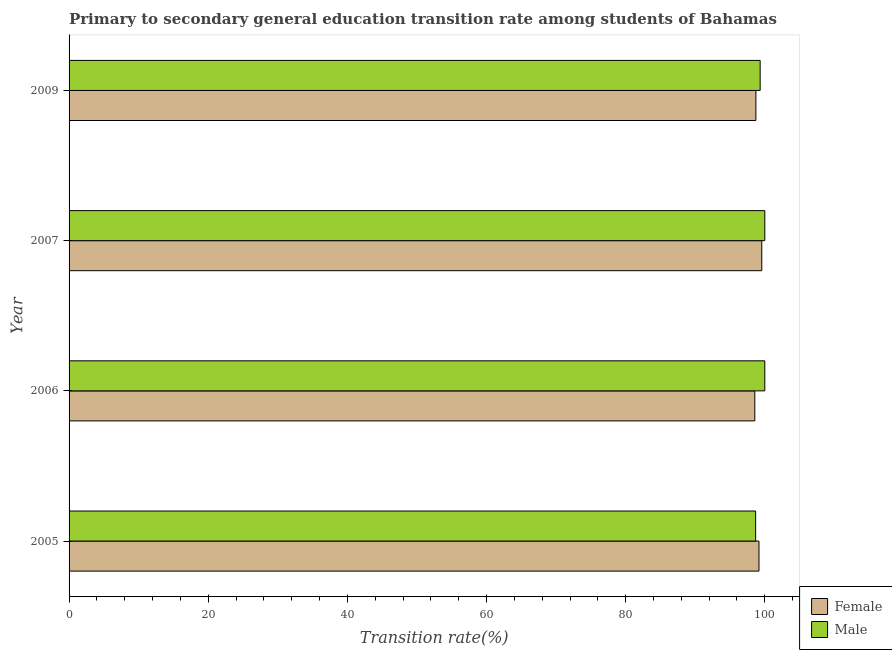How many different coloured bars are there?
Offer a very short reply. 2. How many groups of bars are there?
Your answer should be very brief. 4. Are the number of bars per tick equal to the number of legend labels?
Your response must be concise. Yes. How many bars are there on the 2nd tick from the top?
Make the answer very short. 2. How many bars are there on the 2nd tick from the bottom?
Make the answer very short. 2. What is the transition rate among female students in 2009?
Your answer should be very brief. 98.72. Across all years, what is the maximum transition rate among male students?
Offer a terse response. 100. Across all years, what is the minimum transition rate among male students?
Ensure brevity in your answer.  98.68. In which year was the transition rate among female students minimum?
Make the answer very short. 2006. What is the total transition rate among female students in the graph?
Provide a short and direct response. 396.01. What is the difference between the transition rate among female students in 2007 and that in 2009?
Your answer should be very brief. 0.85. What is the difference between the transition rate among male students in 2005 and the transition rate among female students in 2007?
Your answer should be compact. -0.88. What is the average transition rate among female students per year?
Give a very brief answer. 99. In the year 2009, what is the difference between the transition rate among male students and transition rate among female students?
Make the answer very short. 0.61. In how many years, is the transition rate among male students greater than the average transition rate among male students taken over all years?
Your answer should be very brief. 2. What does the 1st bar from the top in 2006 represents?
Provide a succinct answer. Male. What does the 1st bar from the bottom in 2007 represents?
Your answer should be very brief. Female. Are all the bars in the graph horizontal?
Provide a short and direct response. Yes. What is the difference between two consecutive major ticks on the X-axis?
Make the answer very short. 20. Does the graph contain any zero values?
Offer a terse response. No. Does the graph contain grids?
Offer a terse response. No. How are the legend labels stacked?
Your answer should be compact. Vertical. What is the title of the graph?
Make the answer very short. Primary to secondary general education transition rate among students of Bahamas. Does "Goods and services" appear as one of the legend labels in the graph?
Ensure brevity in your answer.  No. What is the label or title of the X-axis?
Offer a terse response. Transition rate(%). What is the Transition rate(%) in Female in 2005?
Provide a succinct answer. 99.17. What is the Transition rate(%) of Male in 2005?
Your answer should be compact. 98.68. What is the Transition rate(%) in Female in 2006?
Provide a succinct answer. 98.57. What is the Transition rate(%) of Male in 2006?
Make the answer very short. 100. What is the Transition rate(%) of Female in 2007?
Your answer should be very brief. 99.56. What is the Transition rate(%) of Male in 2007?
Offer a terse response. 100. What is the Transition rate(%) in Female in 2009?
Your response must be concise. 98.72. What is the Transition rate(%) in Male in 2009?
Keep it short and to the point. 99.33. Across all years, what is the maximum Transition rate(%) in Female?
Your response must be concise. 99.56. Across all years, what is the maximum Transition rate(%) in Male?
Ensure brevity in your answer.  100. Across all years, what is the minimum Transition rate(%) of Female?
Make the answer very short. 98.57. Across all years, what is the minimum Transition rate(%) in Male?
Offer a very short reply. 98.68. What is the total Transition rate(%) of Female in the graph?
Provide a succinct answer. 396.01. What is the total Transition rate(%) in Male in the graph?
Make the answer very short. 398.01. What is the difference between the Transition rate(%) of Female in 2005 and that in 2006?
Your answer should be compact. 0.6. What is the difference between the Transition rate(%) in Male in 2005 and that in 2006?
Provide a short and direct response. -1.32. What is the difference between the Transition rate(%) in Female in 2005 and that in 2007?
Make the answer very short. -0.4. What is the difference between the Transition rate(%) in Male in 2005 and that in 2007?
Your answer should be compact. -1.32. What is the difference between the Transition rate(%) in Female in 2005 and that in 2009?
Give a very brief answer. 0.45. What is the difference between the Transition rate(%) in Male in 2005 and that in 2009?
Your answer should be very brief. -0.65. What is the difference between the Transition rate(%) in Female in 2006 and that in 2007?
Provide a succinct answer. -1. What is the difference between the Transition rate(%) in Female in 2006 and that in 2009?
Your response must be concise. -0.15. What is the difference between the Transition rate(%) in Male in 2006 and that in 2009?
Make the answer very short. 0.67. What is the difference between the Transition rate(%) in Female in 2007 and that in 2009?
Provide a succinct answer. 0.85. What is the difference between the Transition rate(%) of Male in 2007 and that in 2009?
Provide a short and direct response. 0.67. What is the difference between the Transition rate(%) of Female in 2005 and the Transition rate(%) of Male in 2006?
Offer a terse response. -0.83. What is the difference between the Transition rate(%) of Female in 2005 and the Transition rate(%) of Male in 2007?
Your answer should be very brief. -0.83. What is the difference between the Transition rate(%) of Female in 2005 and the Transition rate(%) of Male in 2009?
Provide a succinct answer. -0.17. What is the difference between the Transition rate(%) in Female in 2006 and the Transition rate(%) in Male in 2007?
Ensure brevity in your answer.  -1.43. What is the difference between the Transition rate(%) in Female in 2006 and the Transition rate(%) in Male in 2009?
Make the answer very short. -0.77. What is the difference between the Transition rate(%) in Female in 2007 and the Transition rate(%) in Male in 2009?
Make the answer very short. 0.23. What is the average Transition rate(%) of Female per year?
Give a very brief answer. 99. What is the average Transition rate(%) of Male per year?
Your response must be concise. 99.5. In the year 2005, what is the difference between the Transition rate(%) of Female and Transition rate(%) of Male?
Your answer should be compact. 0.48. In the year 2006, what is the difference between the Transition rate(%) of Female and Transition rate(%) of Male?
Offer a very short reply. -1.43. In the year 2007, what is the difference between the Transition rate(%) of Female and Transition rate(%) of Male?
Your answer should be very brief. -0.44. In the year 2009, what is the difference between the Transition rate(%) of Female and Transition rate(%) of Male?
Give a very brief answer. -0.61. What is the ratio of the Transition rate(%) of Female in 2005 to that in 2006?
Offer a terse response. 1.01. What is the ratio of the Transition rate(%) of Male in 2005 to that in 2006?
Give a very brief answer. 0.99. What is the ratio of the Transition rate(%) of Female in 2005 to that in 2007?
Provide a succinct answer. 1. What is the ratio of the Transition rate(%) in Male in 2005 to that in 2007?
Provide a succinct answer. 0.99. What is the ratio of the Transition rate(%) of Female in 2006 to that in 2007?
Your answer should be very brief. 0.99. What is the ratio of the Transition rate(%) in Male in 2006 to that in 2007?
Your response must be concise. 1. What is the ratio of the Transition rate(%) of Female in 2006 to that in 2009?
Offer a terse response. 1. What is the ratio of the Transition rate(%) in Male in 2006 to that in 2009?
Offer a terse response. 1.01. What is the ratio of the Transition rate(%) in Female in 2007 to that in 2009?
Your answer should be compact. 1.01. What is the difference between the highest and the second highest Transition rate(%) of Female?
Provide a succinct answer. 0.4. What is the difference between the highest and the lowest Transition rate(%) of Male?
Ensure brevity in your answer.  1.32. 